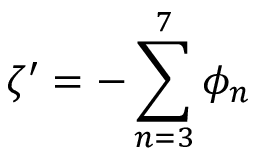<formula> <loc_0><loc_0><loc_500><loc_500>\zeta ^ { \prime } = - \sum _ { n = 3 } ^ { 7 } \phi _ { n }</formula> 